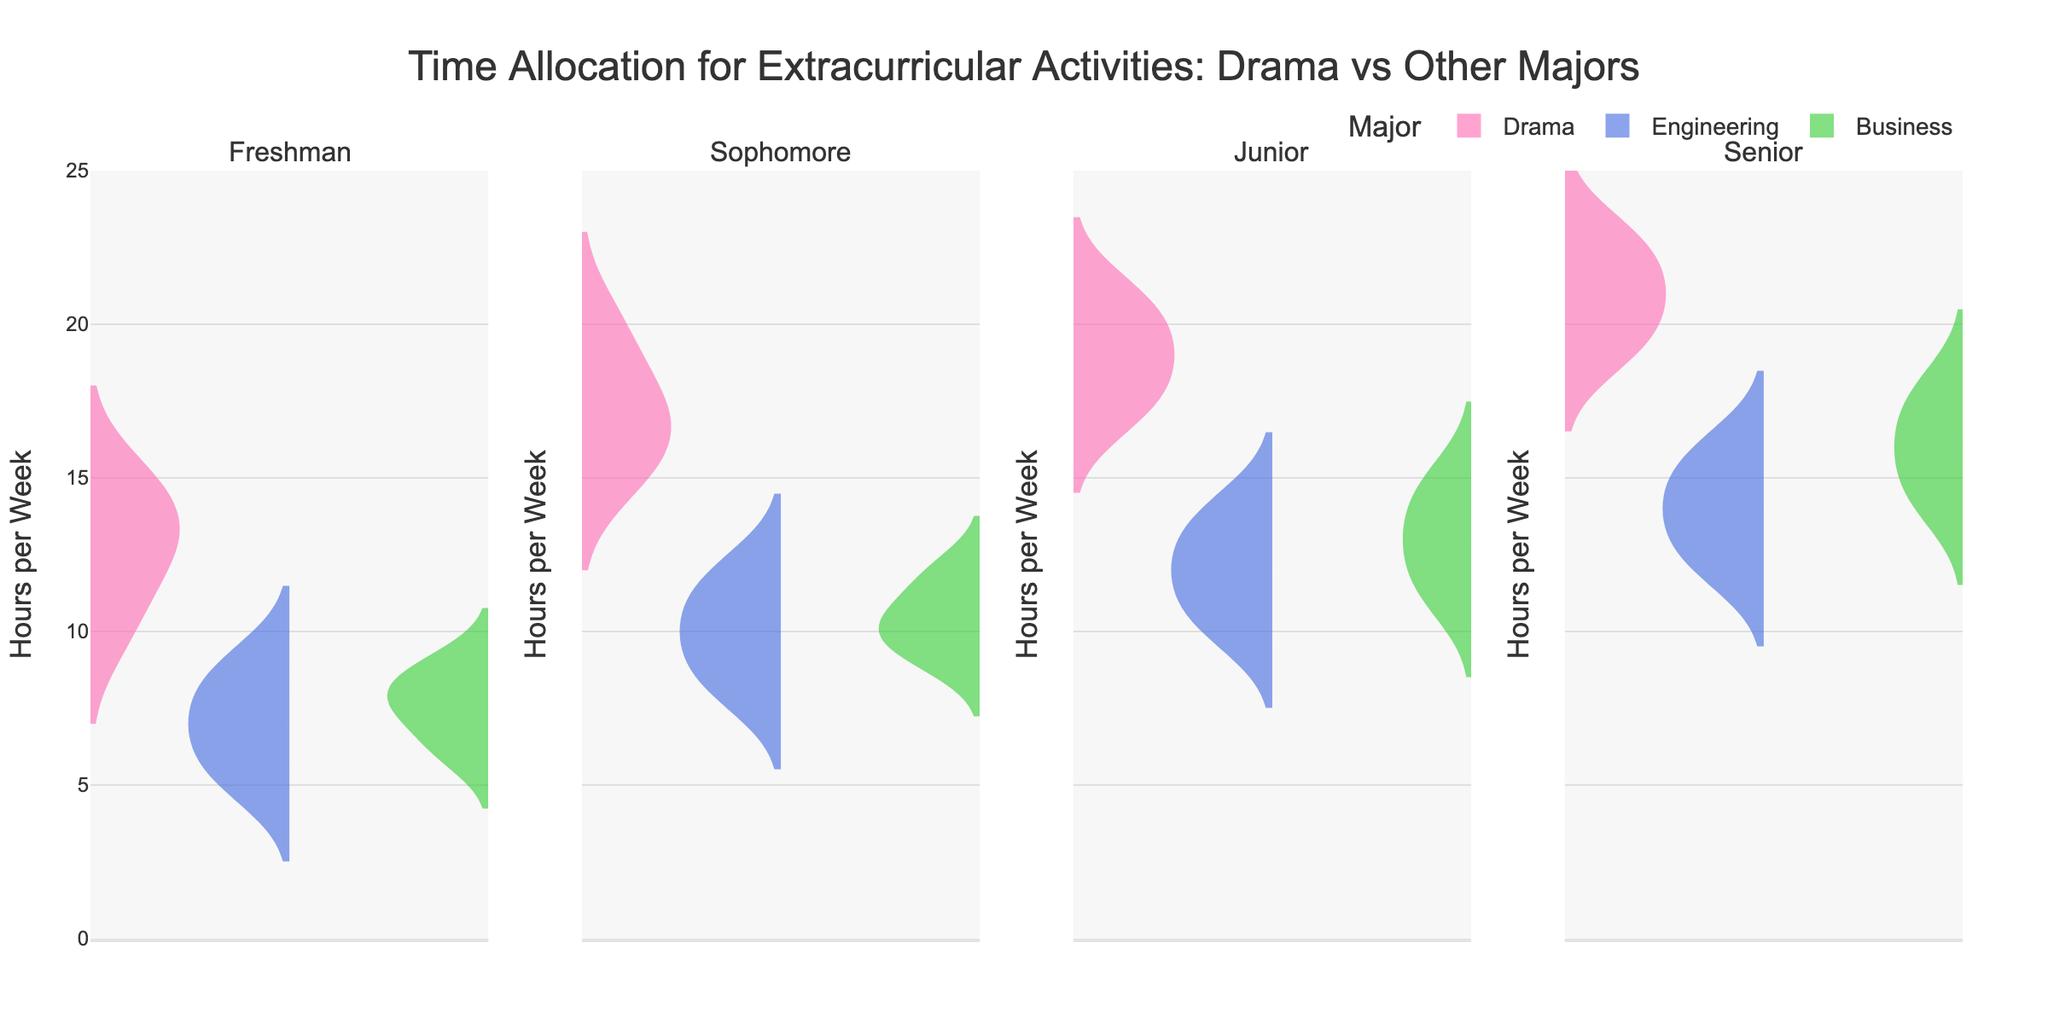What's the title of the figure? The title is usually displayed at the top of the figure and is designed to give a quick summary of what the figure represents. In this case, the title is "Time Allocation for Extracurricular Activities: Drama vs Other Majors".
Answer: "Time Allocation for Extracurricular Activities: Drama vs Other Majors" What time in hours per week did senior drama students allocate the most to extracurricular activities? To determine this, observe the upper bound of the Senior Drama violin plot. The maximum value represented is 23 hours.
Answer: 23 Which major shows the most significant increase in time spent on extracurricular activities from freshman to senior year? Analyze the violin plots for each year and major. For Drama students, the time increases from around 12-15 hours in freshman year to 19-23 hours in senior year, whereas Engineering and Business show more modest increases. Thus, Drama shows the most significant increase.
Answer: Drama How many majors are compared in each academic year for time spent on extracurricular activities? The plot includes violin plots for Drama, Engineering, and Business for each academic year. This makes a total of three majors compared per academic year.
Answer: 3 What's the mean time spent on extracurricular activities for sophomore engineering students? By looking at the mean line (usually shown within the violin), it's observed that the mean time for sophomore engineering students is around 10 hours per week.
Answer: 10 Compare the average time spent on extracurricular activities between senior Drama students and senior Business students. For senior Drama students, the mean line is around 21 hours. For senior Business students, the mean line is around 16 hours. Therefore, senior Drama students spend on average 5 more hours per week on extracurricular activities than senior Business students.
Answer: 5 more hours Which academic year shows the smallest range of time spent on extracurricular activities for Drama majors? The range can be observed by looking at the top and bottom of the violin plots. For Drama majors, the smallest range is observed in the Freshman year where it varies from 10 to 15 hours (range of 5).
Answer: Freshman What is the most common amount of time spent on extracurricular activities by junior Drama students? The most common value, or mode, is typically indicated by the widest part of the violin plot. For junior Drama students, the widest part is around 20 hours per week.
Answer: 20 hours Are there any outliers in the time spent on extracurricular activities for any major or year? Outliers in violin plots can sometimes be represented by points outside the main distribution. Since no such points are shown in this specific chart, there are no identified outliers.
Answer: No 